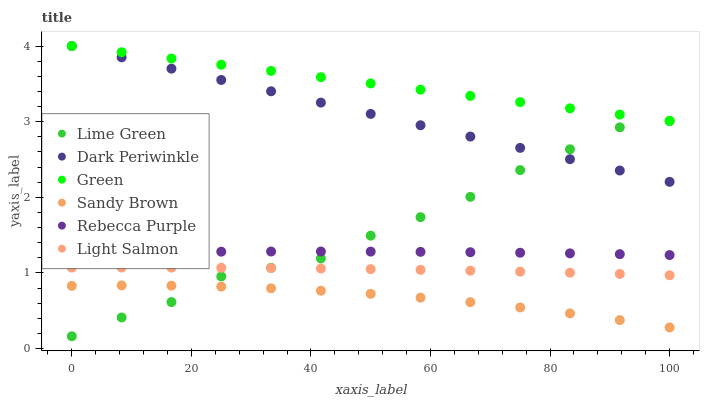Does Sandy Brown have the minimum area under the curve?
Answer yes or no. Yes. Does Green have the maximum area under the curve?
Answer yes or no. Yes. Does Green have the minimum area under the curve?
Answer yes or no. No. Does Sandy Brown have the maximum area under the curve?
Answer yes or no. No. Is Green the smoothest?
Answer yes or no. Yes. Is Lime Green the roughest?
Answer yes or no. Yes. Is Sandy Brown the smoothest?
Answer yes or no. No. Is Sandy Brown the roughest?
Answer yes or no. No. Does Lime Green have the lowest value?
Answer yes or no. Yes. Does Sandy Brown have the lowest value?
Answer yes or no. No. Does Dark Periwinkle have the highest value?
Answer yes or no. Yes. Does Sandy Brown have the highest value?
Answer yes or no. No. Is Sandy Brown less than Light Salmon?
Answer yes or no. Yes. Is Dark Periwinkle greater than Light Salmon?
Answer yes or no. Yes. Does Rebecca Purple intersect Lime Green?
Answer yes or no. Yes. Is Rebecca Purple less than Lime Green?
Answer yes or no. No. Is Rebecca Purple greater than Lime Green?
Answer yes or no. No. Does Sandy Brown intersect Light Salmon?
Answer yes or no. No. 